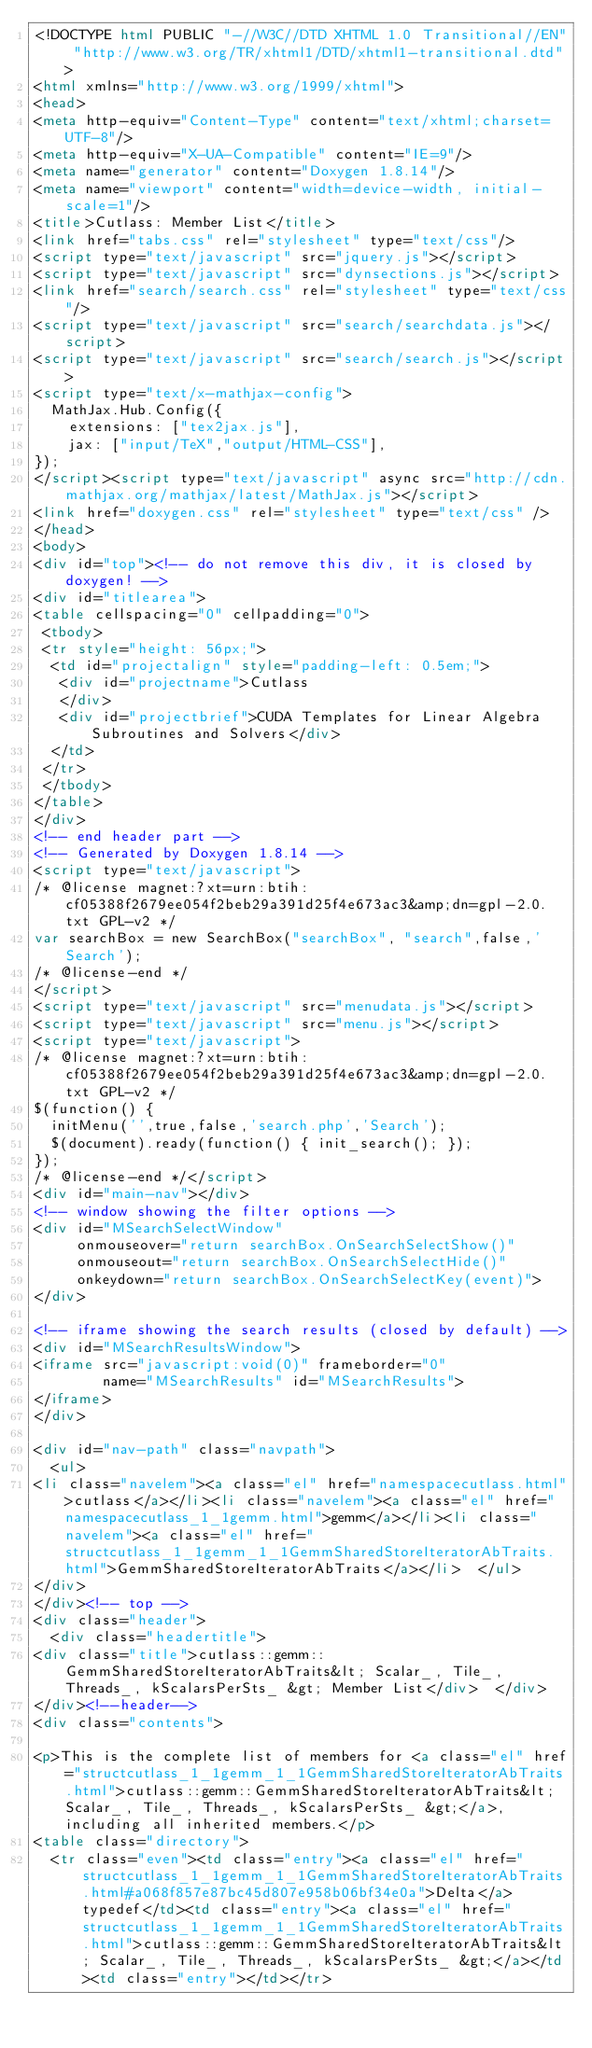<code> <loc_0><loc_0><loc_500><loc_500><_HTML_><!DOCTYPE html PUBLIC "-//W3C//DTD XHTML 1.0 Transitional//EN" "http://www.w3.org/TR/xhtml1/DTD/xhtml1-transitional.dtd">
<html xmlns="http://www.w3.org/1999/xhtml">
<head>
<meta http-equiv="Content-Type" content="text/xhtml;charset=UTF-8"/>
<meta http-equiv="X-UA-Compatible" content="IE=9"/>
<meta name="generator" content="Doxygen 1.8.14"/>
<meta name="viewport" content="width=device-width, initial-scale=1"/>
<title>Cutlass: Member List</title>
<link href="tabs.css" rel="stylesheet" type="text/css"/>
<script type="text/javascript" src="jquery.js"></script>
<script type="text/javascript" src="dynsections.js"></script>
<link href="search/search.css" rel="stylesheet" type="text/css"/>
<script type="text/javascript" src="search/searchdata.js"></script>
<script type="text/javascript" src="search/search.js"></script>
<script type="text/x-mathjax-config">
  MathJax.Hub.Config({
    extensions: ["tex2jax.js"],
    jax: ["input/TeX","output/HTML-CSS"],
});
</script><script type="text/javascript" async src="http://cdn.mathjax.org/mathjax/latest/MathJax.js"></script>
<link href="doxygen.css" rel="stylesheet" type="text/css" />
</head>
<body>
<div id="top"><!-- do not remove this div, it is closed by doxygen! -->
<div id="titlearea">
<table cellspacing="0" cellpadding="0">
 <tbody>
 <tr style="height: 56px;">
  <td id="projectalign" style="padding-left: 0.5em;">
   <div id="projectname">Cutlass
   </div>
   <div id="projectbrief">CUDA Templates for Linear Algebra Subroutines and Solvers</div>
  </td>
 </tr>
 </tbody>
</table>
</div>
<!-- end header part -->
<!-- Generated by Doxygen 1.8.14 -->
<script type="text/javascript">
/* @license magnet:?xt=urn:btih:cf05388f2679ee054f2beb29a391d25f4e673ac3&amp;dn=gpl-2.0.txt GPL-v2 */
var searchBox = new SearchBox("searchBox", "search",false,'Search');
/* @license-end */
</script>
<script type="text/javascript" src="menudata.js"></script>
<script type="text/javascript" src="menu.js"></script>
<script type="text/javascript">
/* @license magnet:?xt=urn:btih:cf05388f2679ee054f2beb29a391d25f4e673ac3&amp;dn=gpl-2.0.txt GPL-v2 */
$(function() {
  initMenu('',true,false,'search.php','Search');
  $(document).ready(function() { init_search(); });
});
/* @license-end */</script>
<div id="main-nav"></div>
<!-- window showing the filter options -->
<div id="MSearchSelectWindow"
     onmouseover="return searchBox.OnSearchSelectShow()"
     onmouseout="return searchBox.OnSearchSelectHide()"
     onkeydown="return searchBox.OnSearchSelectKey(event)">
</div>

<!-- iframe showing the search results (closed by default) -->
<div id="MSearchResultsWindow">
<iframe src="javascript:void(0)" frameborder="0" 
        name="MSearchResults" id="MSearchResults">
</iframe>
</div>

<div id="nav-path" class="navpath">
  <ul>
<li class="navelem"><a class="el" href="namespacecutlass.html">cutlass</a></li><li class="navelem"><a class="el" href="namespacecutlass_1_1gemm.html">gemm</a></li><li class="navelem"><a class="el" href="structcutlass_1_1gemm_1_1GemmSharedStoreIteratorAbTraits.html">GemmSharedStoreIteratorAbTraits</a></li>  </ul>
</div>
</div><!-- top -->
<div class="header">
  <div class="headertitle">
<div class="title">cutlass::gemm::GemmSharedStoreIteratorAbTraits&lt; Scalar_, Tile_, Threads_, kScalarsPerSts_ &gt; Member List</div>  </div>
</div><!--header-->
<div class="contents">

<p>This is the complete list of members for <a class="el" href="structcutlass_1_1gemm_1_1GemmSharedStoreIteratorAbTraits.html">cutlass::gemm::GemmSharedStoreIteratorAbTraits&lt; Scalar_, Tile_, Threads_, kScalarsPerSts_ &gt;</a>, including all inherited members.</p>
<table class="directory">
  <tr class="even"><td class="entry"><a class="el" href="structcutlass_1_1gemm_1_1GemmSharedStoreIteratorAbTraits.html#a068f857e87bc45d807e958b06bf34e0a">Delta</a> typedef</td><td class="entry"><a class="el" href="structcutlass_1_1gemm_1_1GemmSharedStoreIteratorAbTraits.html">cutlass::gemm::GemmSharedStoreIteratorAbTraits&lt; Scalar_, Tile_, Threads_, kScalarsPerSts_ &gt;</a></td><td class="entry"></td></tr></code> 